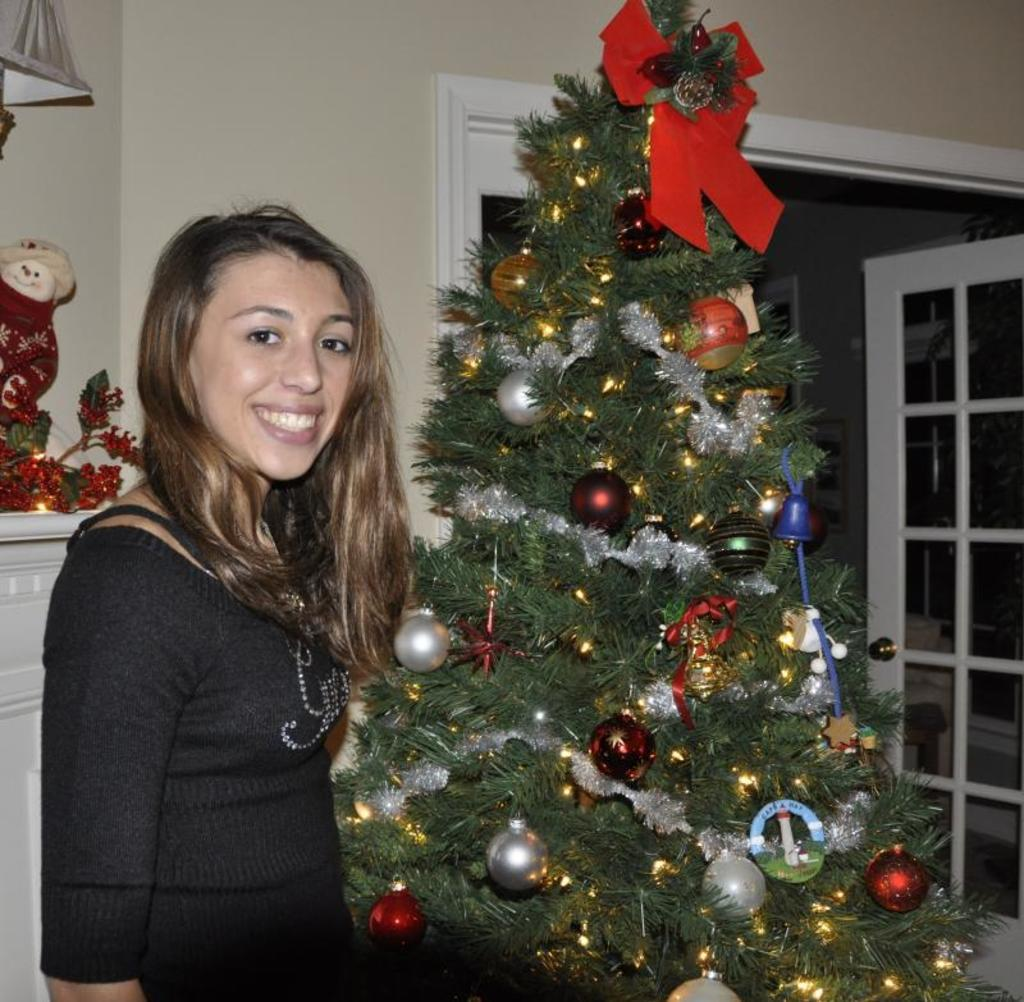Who is present in the image? There is a woman in the image. What is the woman wearing? The woman is wearing a black dress. What is the woman's expression in the image? The woman is smiling. What season might the image be associated with? The presence of a Christmas tree in the image suggests it might be associated with the holiday season. What objects can be seen in the image? There are objects placed in the image. What architectural feature is visible in the background of the image? There are glass doors in the background of the image. What type of pipe can be seen in the woman's hand in the image? There is no pipe present in the woman's hand or anywhere else in the image. Who is the woman's uncle, and is he present in the image? There is no mention of an uncle in the image or the provided facts, so it cannot be determined if he is present. 